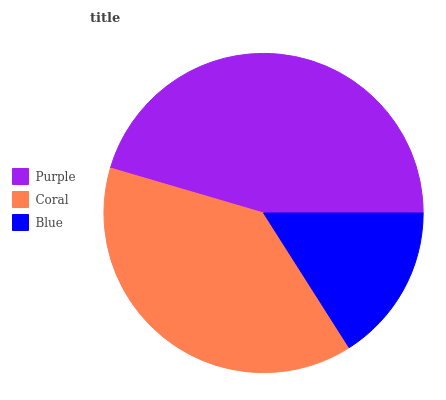Is Blue the minimum?
Answer yes or no. Yes. Is Purple the maximum?
Answer yes or no. Yes. Is Coral the minimum?
Answer yes or no. No. Is Coral the maximum?
Answer yes or no. No. Is Purple greater than Coral?
Answer yes or no. Yes. Is Coral less than Purple?
Answer yes or no. Yes. Is Coral greater than Purple?
Answer yes or no. No. Is Purple less than Coral?
Answer yes or no. No. Is Coral the high median?
Answer yes or no. Yes. Is Coral the low median?
Answer yes or no. Yes. Is Blue the high median?
Answer yes or no. No. Is Blue the low median?
Answer yes or no. No. 